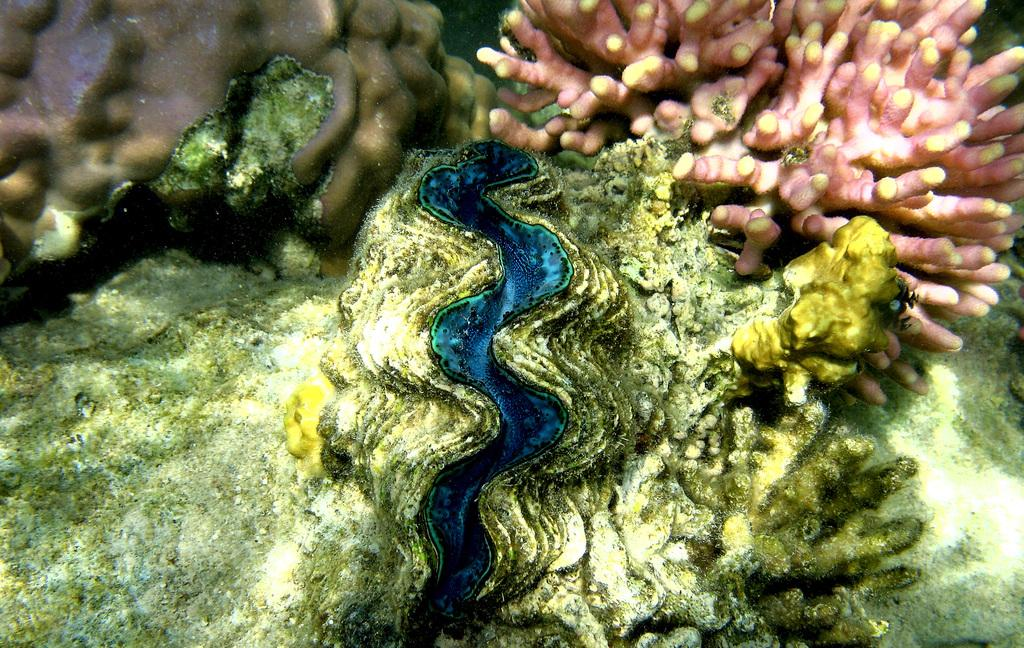What type of plants are visible in the image? There are sea plants in the image. What type of connection is visible between the sea plants in the image? There is no specific connection visible between the sea plants in the image; they are simply depicted as individual plants. 